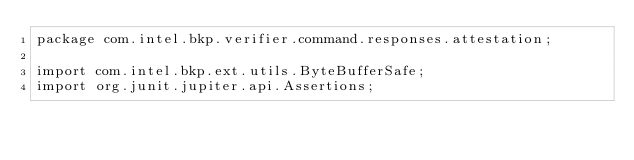<code> <loc_0><loc_0><loc_500><loc_500><_Java_>package com.intel.bkp.verifier.command.responses.attestation;

import com.intel.bkp.ext.utils.ByteBufferSafe;
import org.junit.jupiter.api.Assertions;</code> 